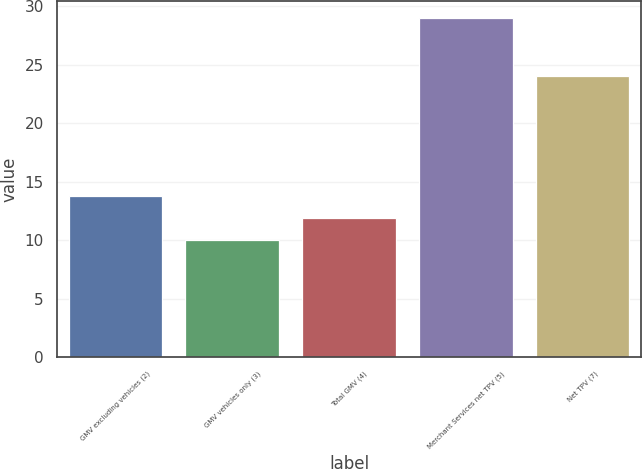<chart> <loc_0><loc_0><loc_500><loc_500><bar_chart><fcel>GMV excluding vehicles (2)<fcel>GMV vehicles only (3)<fcel>Total GMV (4)<fcel>Merchant Services net TPV (5)<fcel>Net TPV (7)<nl><fcel>13.8<fcel>10<fcel>11.9<fcel>29<fcel>24<nl></chart> 